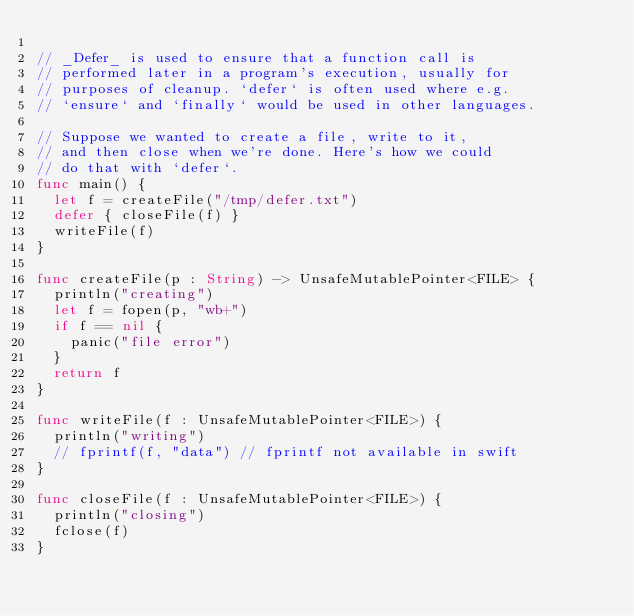Convert code to text. <code><loc_0><loc_0><loc_500><loc_500><_Swift_>
// _Defer_ is used to ensure that a function call is
// performed later in a program's execution, usually for
// purposes of cleanup. `defer` is often used where e.g.
// `ensure` and `finally` would be used in other languages.

// Suppose we wanted to create a file, write to it,
// and then close when we're done. Here's how we could
// do that with `defer`.
func main() {
	let f = createFile("/tmp/defer.txt")
	defer { closeFile(f) }
	writeFile(f)
}

func createFile(p : String) -> UnsafeMutablePointer<FILE> {
	println("creating")
	let f = fopen(p, "wb+")
	if f == nil {
		panic("file error")
	}
	return f
}

func writeFile(f : UnsafeMutablePointer<FILE>) {
	println("writing")
	// fprintf(f, "data") // fprintf not available in swift
}

func closeFile(f : UnsafeMutablePointer<FILE>) {
	println("closing")
	fclose(f)
}
</code> 